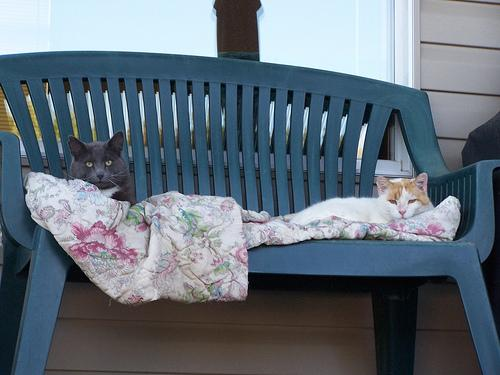What kind of prey do these animals hunt?

Choices:
A) large
B) deer
C) small
D) bears small 